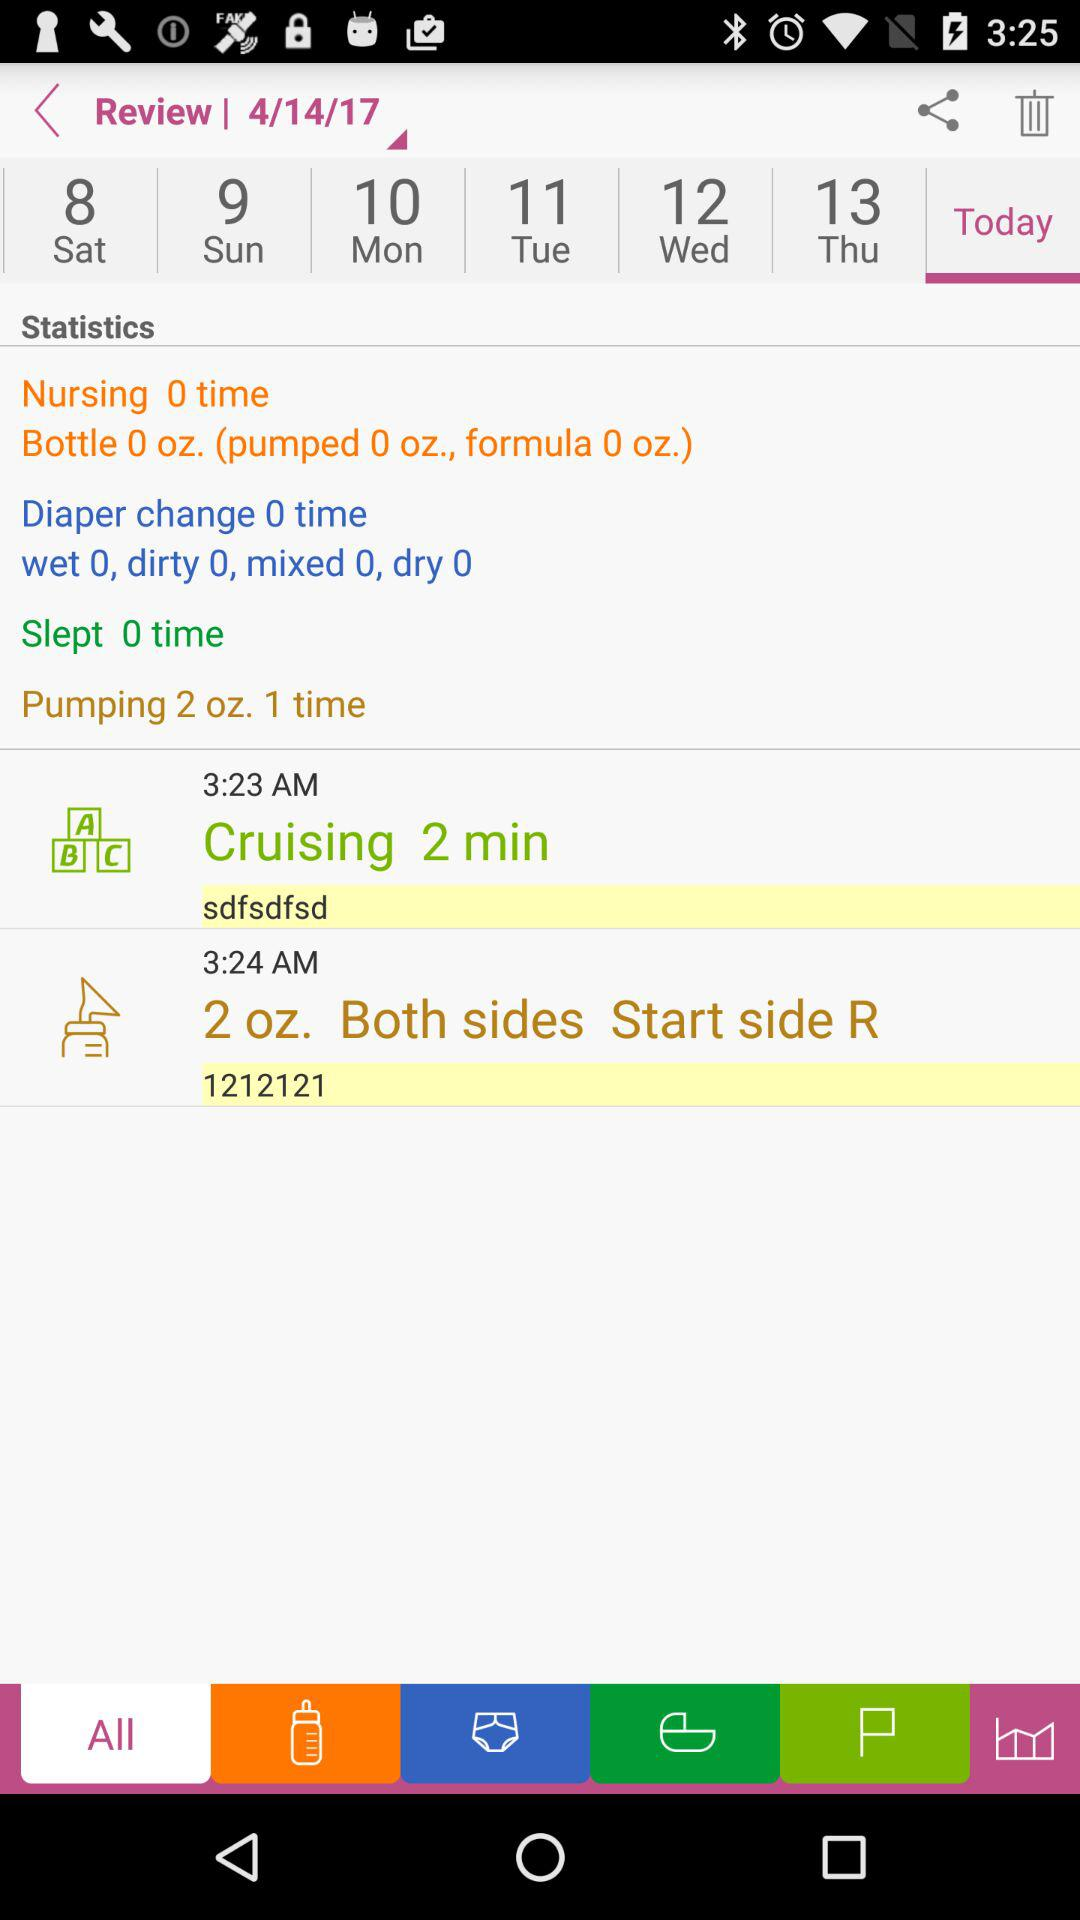What is the cruising time? The cruising time is 3:23 AM. 